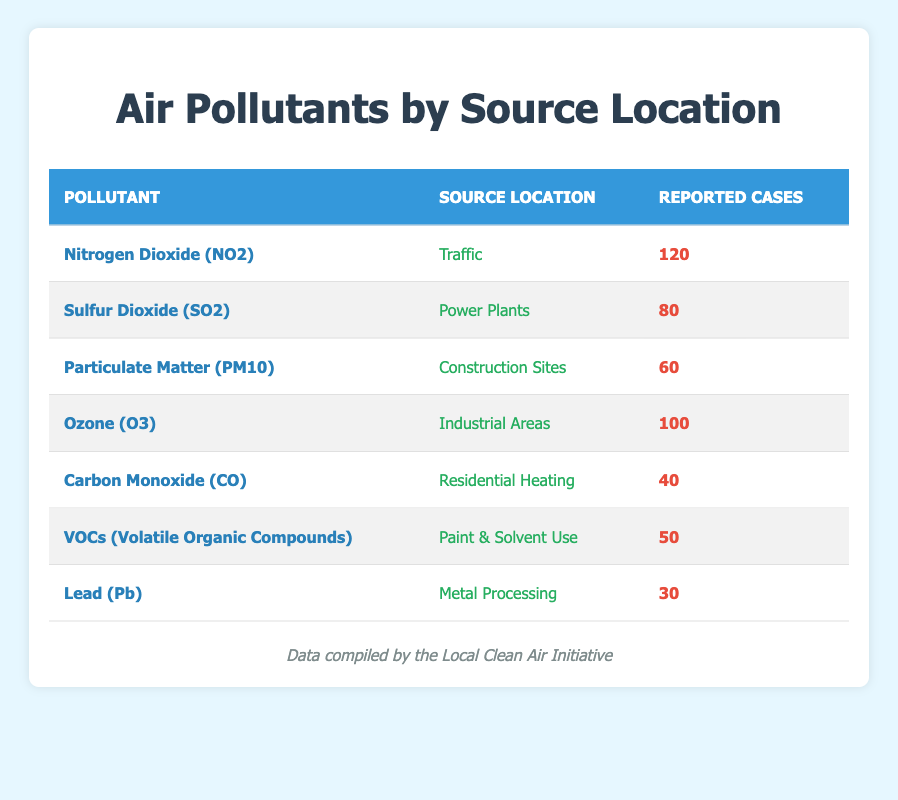What is the reported number of cases for Nitrogen Dioxide (NO2)? According to the table, the reported number of cases for Nitrogen Dioxide (NO2) is listed directly in the row corresponding to this pollutant. It shows 120 cases.
Answer: 120 Which source location has the highest number of reported cases? By scanning each row in the table, we find that Traffic has 120 cases for Nitrogen Dioxide (NO2), which is the highest reported number compared to the other source locations.
Answer: Traffic What is the total number of reported cases for all pollutants? To find the total number of reported cases, we need to sum up the reported cases from all pollutants listed in the table: 120 (NO2) + 80 (SO2) + 60 (PM10) + 100 (O3) + 40 (CO) + 50 (VOCs) + 30 (Pb) = 480.
Answer: 480 Is there a pollutant reported from Residential Heating? We refer to the table to check for any pollutants associated with Residential Heating. The table shows that Carbon Monoxide (CO) is reported from this source, confirming that there is indeed a pollutant associated with Residential Heating.
Answer: Yes How many more cases are reported for Ozone (O3) than for Lead (Pb)? We find the reported cases for both Ozone (O3) and Lead (Pb) in the table: Ozone (O3) has 100 cases, while Lead (Pb) has 30 cases. To find the difference, we calculate 100 - 30 = 70.
Answer: 70 Which pollutants have reported cases below 50? Looking through the table, we check each pollutant's reported cases. We find that only Lead (Pb) with 30 cases and Carbon Monoxide (CO) with 40 cases are below 50.
Answer: Lead (Pb) and Carbon Monoxide (CO) What is the average number of reported cases for pollutants associated with traffic and power plants? First, we identify the pollutants from Traffic (Nitrogen Dioxide (NO2): 120 cases) and Power Plants (Sulfur Dioxide (SO2): 80 cases). Then we average these totals: (120 + 80) / 2 = 200 / 2 = 100.
Answer: 100 Is it true that VOCs have more reported cases than Particulate Matter (PM10)? In the table, VOCs have 50 cases and Particulate Matter (PM10) has 60 cases. Since 50 is less than 60, the statement is false.
Answer: No Which source location is associated with the lowest number of reported cases? The table lists the reported cases for each pollutant. By comparing the values, we see that Lead (Pb) from Metal Processing with only 30 cases is the lowest among all reported cases.
Answer: Metal Processing 